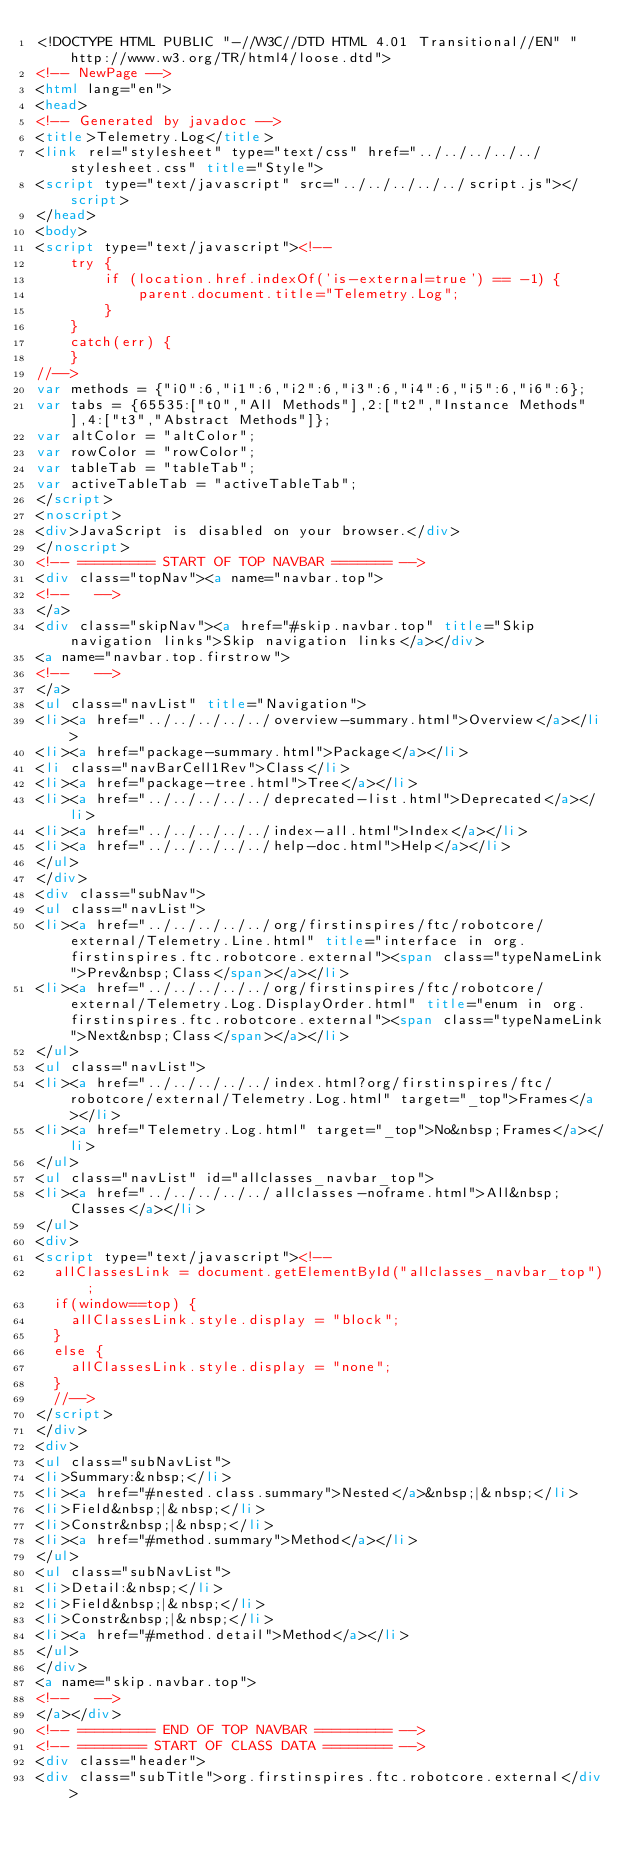<code> <loc_0><loc_0><loc_500><loc_500><_HTML_><!DOCTYPE HTML PUBLIC "-//W3C//DTD HTML 4.01 Transitional//EN" "http://www.w3.org/TR/html4/loose.dtd">
<!-- NewPage -->
<html lang="en">
<head>
<!-- Generated by javadoc -->
<title>Telemetry.Log</title>
<link rel="stylesheet" type="text/css" href="../../../../../stylesheet.css" title="Style">
<script type="text/javascript" src="../../../../../script.js"></script>
</head>
<body>
<script type="text/javascript"><!--
    try {
        if (location.href.indexOf('is-external=true') == -1) {
            parent.document.title="Telemetry.Log";
        }
    }
    catch(err) {
    }
//-->
var methods = {"i0":6,"i1":6,"i2":6,"i3":6,"i4":6,"i5":6,"i6":6};
var tabs = {65535:["t0","All Methods"],2:["t2","Instance Methods"],4:["t3","Abstract Methods"]};
var altColor = "altColor";
var rowColor = "rowColor";
var tableTab = "tableTab";
var activeTableTab = "activeTableTab";
</script>
<noscript>
<div>JavaScript is disabled on your browser.</div>
</noscript>
<!-- ========= START OF TOP NAVBAR ======= -->
<div class="topNav"><a name="navbar.top">
<!--   -->
</a>
<div class="skipNav"><a href="#skip.navbar.top" title="Skip navigation links">Skip navigation links</a></div>
<a name="navbar.top.firstrow">
<!--   -->
</a>
<ul class="navList" title="Navigation">
<li><a href="../../../../../overview-summary.html">Overview</a></li>
<li><a href="package-summary.html">Package</a></li>
<li class="navBarCell1Rev">Class</li>
<li><a href="package-tree.html">Tree</a></li>
<li><a href="../../../../../deprecated-list.html">Deprecated</a></li>
<li><a href="../../../../../index-all.html">Index</a></li>
<li><a href="../../../../../help-doc.html">Help</a></li>
</ul>
</div>
<div class="subNav">
<ul class="navList">
<li><a href="../../../../../org/firstinspires/ftc/robotcore/external/Telemetry.Line.html" title="interface in org.firstinspires.ftc.robotcore.external"><span class="typeNameLink">Prev&nbsp;Class</span></a></li>
<li><a href="../../../../../org/firstinspires/ftc/robotcore/external/Telemetry.Log.DisplayOrder.html" title="enum in org.firstinspires.ftc.robotcore.external"><span class="typeNameLink">Next&nbsp;Class</span></a></li>
</ul>
<ul class="navList">
<li><a href="../../../../../index.html?org/firstinspires/ftc/robotcore/external/Telemetry.Log.html" target="_top">Frames</a></li>
<li><a href="Telemetry.Log.html" target="_top">No&nbsp;Frames</a></li>
</ul>
<ul class="navList" id="allclasses_navbar_top">
<li><a href="../../../../../allclasses-noframe.html">All&nbsp;Classes</a></li>
</ul>
<div>
<script type="text/javascript"><!--
  allClassesLink = document.getElementById("allclasses_navbar_top");
  if(window==top) {
    allClassesLink.style.display = "block";
  }
  else {
    allClassesLink.style.display = "none";
  }
  //-->
</script>
</div>
<div>
<ul class="subNavList">
<li>Summary:&nbsp;</li>
<li><a href="#nested.class.summary">Nested</a>&nbsp;|&nbsp;</li>
<li>Field&nbsp;|&nbsp;</li>
<li>Constr&nbsp;|&nbsp;</li>
<li><a href="#method.summary">Method</a></li>
</ul>
<ul class="subNavList">
<li>Detail:&nbsp;</li>
<li>Field&nbsp;|&nbsp;</li>
<li>Constr&nbsp;|&nbsp;</li>
<li><a href="#method.detail">Method</a></li>
</ul>
</div>
<a name="skip.navbar.top">
<!--   -->
</a></div>
<!-- ========= END OF TOP NAVBAR ========= -->
<!-- ======== START OF CLASS DATA ======== -->
<div class="header">
<div class="subTitle">org.firstinspires.ftc.robotcore.external</div></code> 